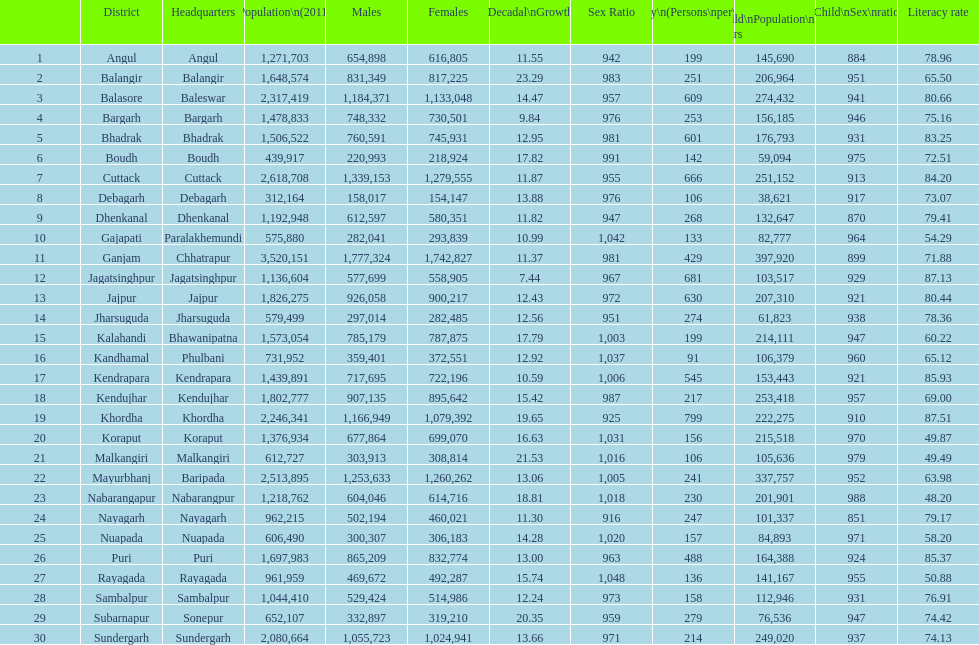What is the disparity in the number of children between koraput and puri? 51,130. 